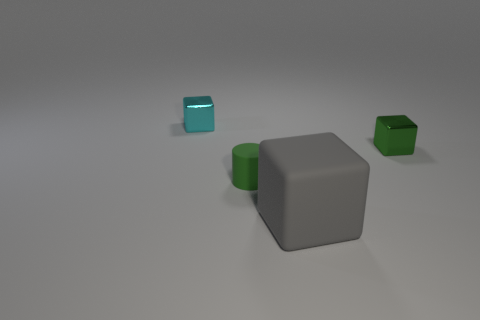What number of other things are there of the same color as the big matte cube?
Give a very brief answer. 0. What is the color of the tiny cube to the left of the tiny green shiny block?
Provide a short and direct response. Cyan. Is there another matte cube of the same size as the green block?
Provide a succinct answer. No. What material is the cyan object that is the same size as the green matte object?
Ensure brevity in your answer.  Metal. What number of things are either things in front of the green cube or cubes to the right of the cyan cube?
Your response must be concise. 3. Is there another large thing of the same shape as the green metallic object?
Ensure brevity in your answer.  Yes. How many matte things are either cyan objects or tiny red balls?
Offer a terse response. 0. What shape is the cyan object?
Offer a terse response. Cube. What number of tiny cylinders are the same material as the gray block?
Your answer should be compact. 1. What color is the cube that is the same material as the green cylinder?
Provide a short and direct response. Gray. 